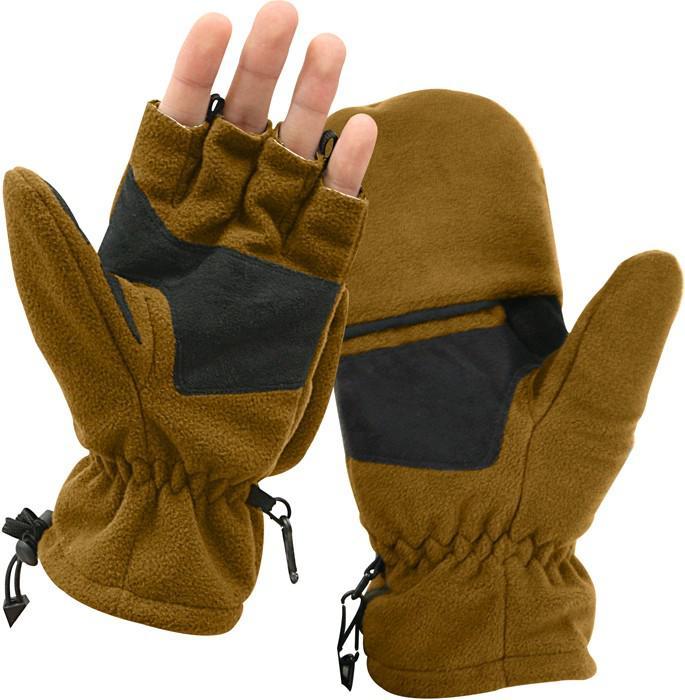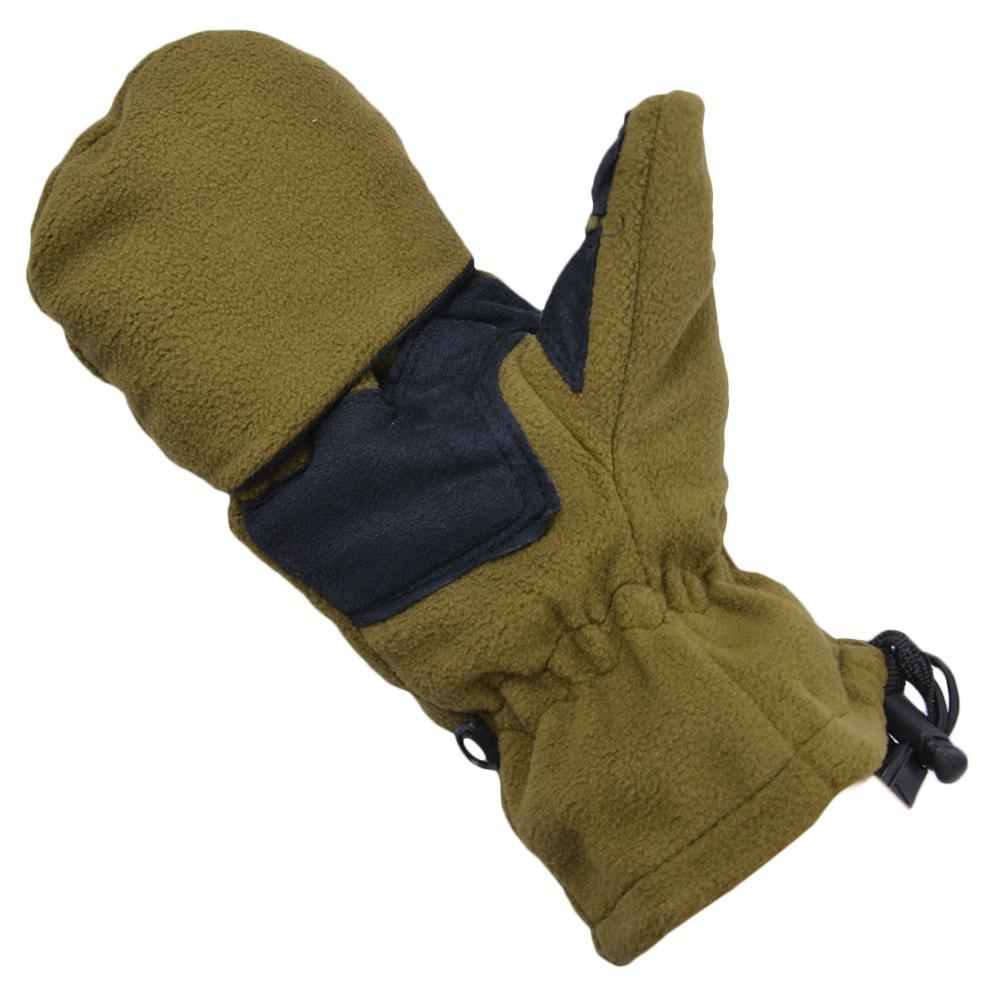The first image is the image on the left, the second image is the image on the right. Assess this claim about the two images: "One image shows a pair of mittens with half-fingers exposed on one mitt only.". Correct or not? Answer yes or no. Yes. The first image is the image on the left, the second image is the image on the right. Considering the images on both sides, is "Two of the gloves can be seen to have a woodland camouflage pattern." valid? Answer yes or no. No. 